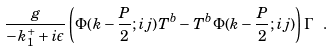Convert formula to latex. <formula><loc_0><loc_0><loc_500><loc_500>\frac { g } { - k _ { 1 } ^ { + } + i \epsilon } \left ( \Phi ( k - \frac { P } { 2 } ; i j ) T ^ { b } - T ^ { b } \Phi ( k - \frac { P } { 2 } ; i j ) \right ) \Gamma \ .</formula> 